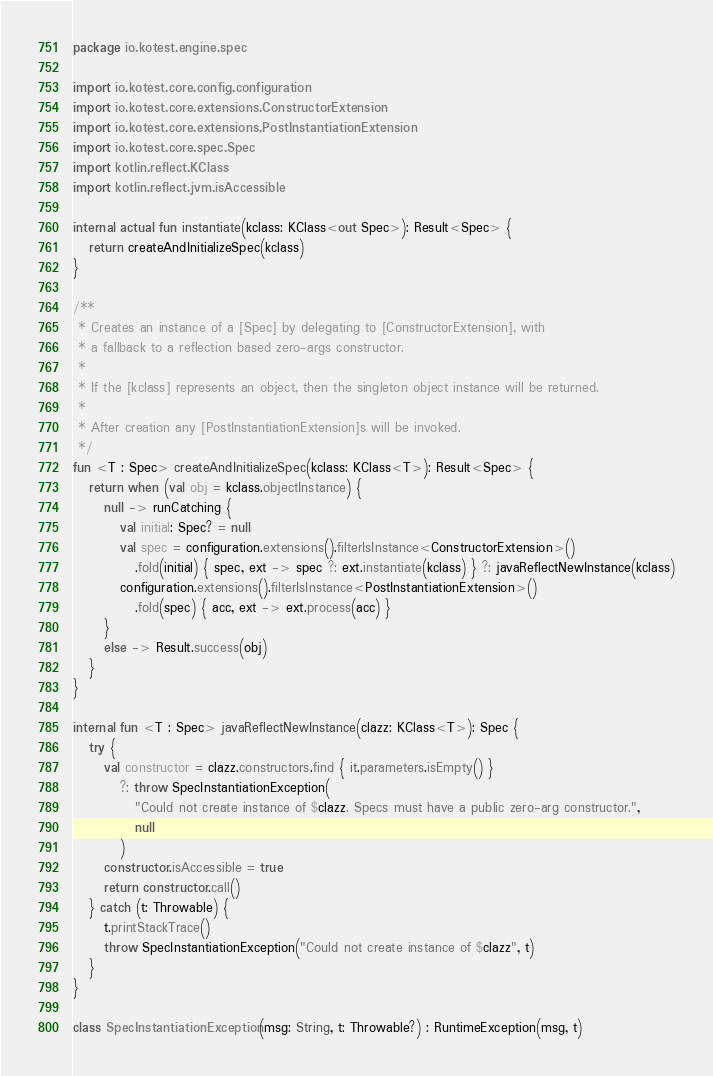Convert code to text. <code><loc_0><loc_0><loc_500><loc_500><_Kotlin_>package io.kotest.engine.spec

import io.kotest.core.config.configuration
import io.kotest.core.extensions.ConstructorExtension
import io.kotest.core.extensions.PostInstantiationExtension
import io.kotest.core.spec.Spec
import kotlin.reflect.KClass
import kotlin.reflect.jvm.isAccessible

internal actual fun instantiate(kclass: KClass<out Spec>): Result<Spec> {
   return createAndInitializeSpec(kclass)
}

/**
 * Creates an instance of a [Spec] by delegating to [ConstructorExtension], with
 * a fallback to a reflection based zero-args constructor.
 *
 * If the [kclass] represents an object, then the singleton object instance will be returned.
 *
 * After creation any [PostInstantiationExtension]s will be invoked.
 */
fun <T : Spec> createAndInitializeSpec(kclass: KClass<T>): Result<Spec> {
   return when (val obj = kclass.objectInstance) {
      null -> runCatching {
         val initial: Spec? = null
         val spec = configuration.extensions().filterIsInstance<ConstructorExtension>()
            .fold(initial) { spec, ext -> spec ?: ext.instantiate(kclass) } ?: javaReflectNewInstance(kclass)
         configuration.extensions().filterIsInstance<PostInstantiationExtension>()
            .fold(spec) { acc, ext -> ext.process(acc) }
      }
      else -> Result.success(obj)
   }
}

internal fun <T : Spec> javaReflectNewInstance(clazz: KClass<T>): Spec {
   try {
      val constructor = clazz.constructors.find { it.parameters.isEmpty() }
         ?: throw SpecInstantiationException(
            "Could not create instance of $clazz. Specs must have a public zero-arg constructor.",
            null
         )
      constructor.isAccessible = true
      return constructor.call()
   } catch (t: Throwable) {
      t.printStackTrace()
      throw SpecInstantiationException("Could not create instance of $clazz", t)
   }
}

class SpecInstantiationException(msg: String, t: Throwable?) : RuntimeException(msg, t)
</code> 